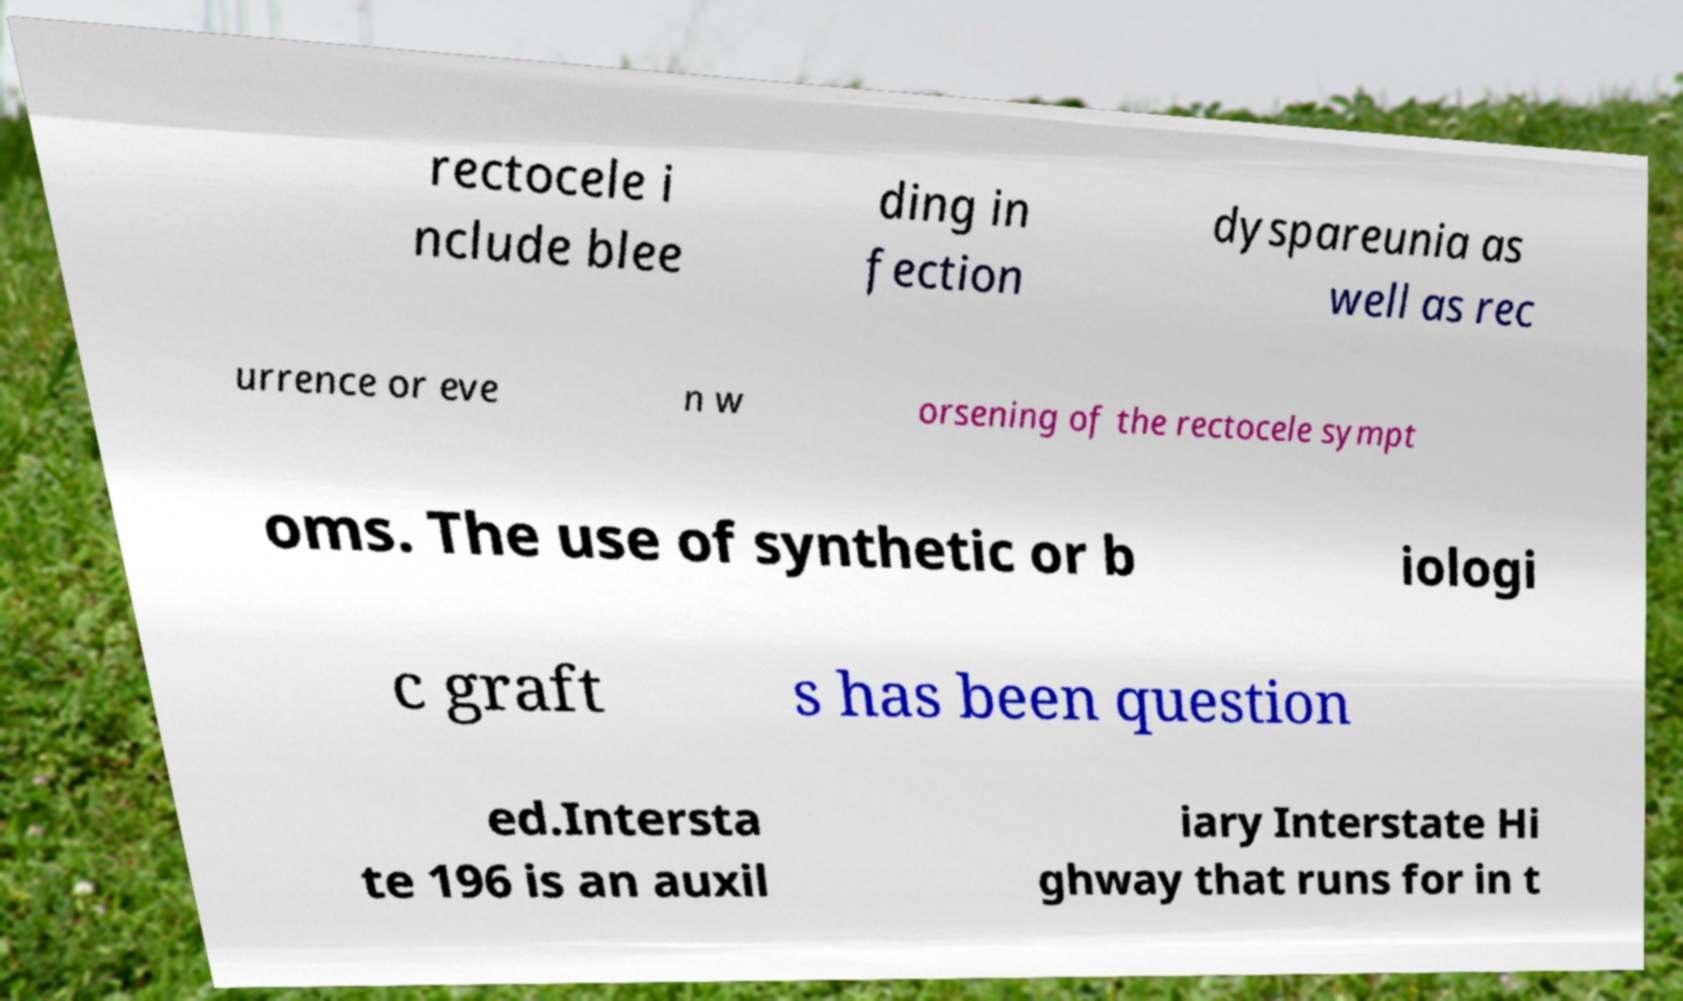There's text embedded in this image that I need extracted. Can you transcribe it verbatim? rectocele i nclude blee ding in fection dyspareunia as well as rec urrence or eve n w orsening of the rectocele sympt oms. The use of synthetic or b iologi c graft s has been question ed.Intersta te 196 is an auxil iary Interstate Hi ghway that runs for in t 